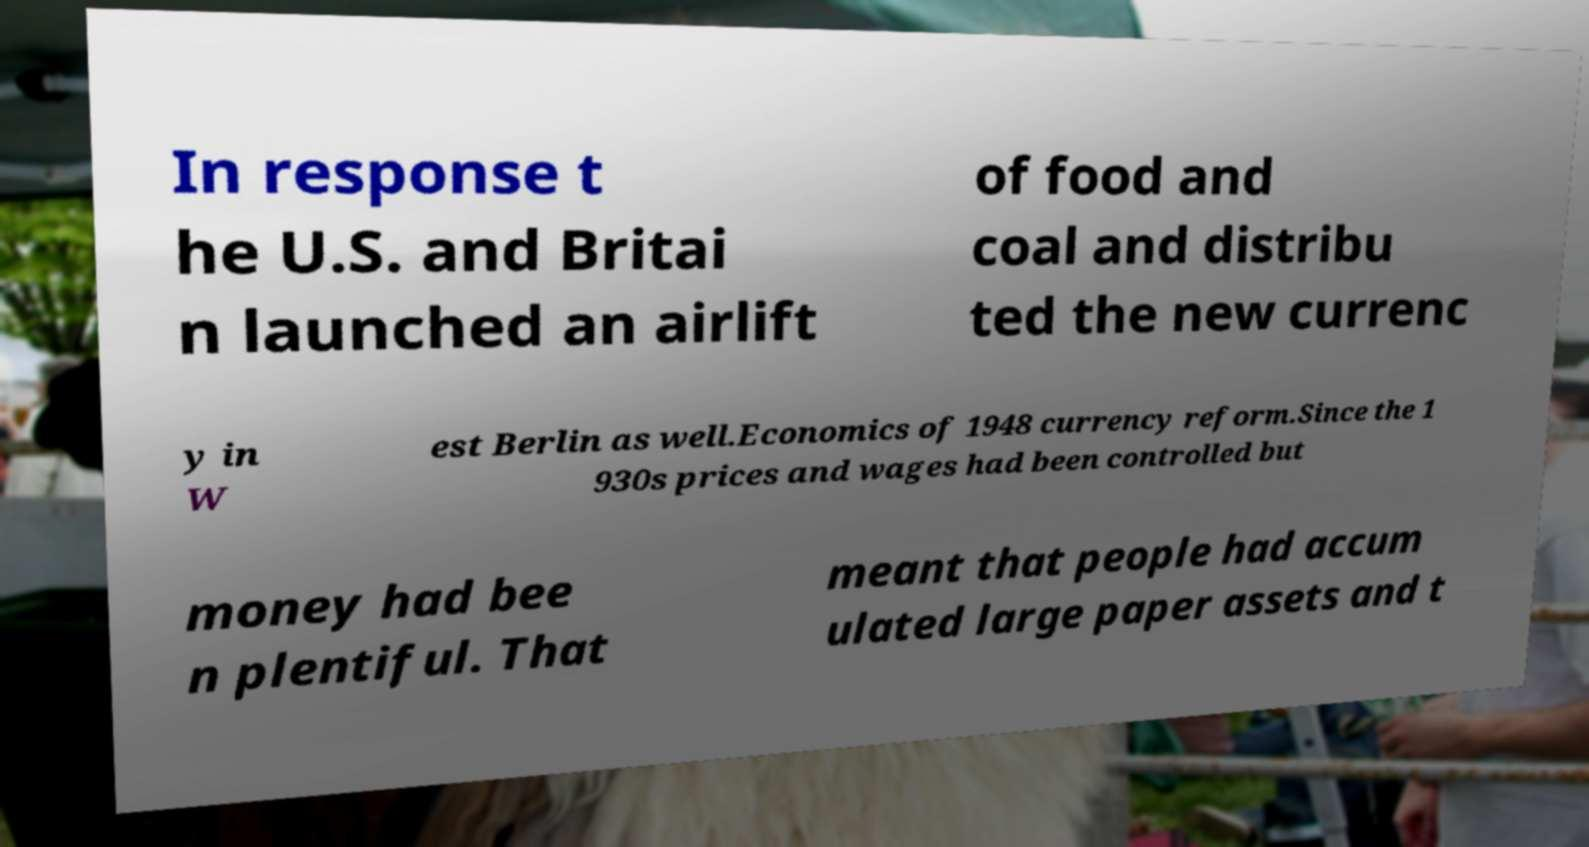I need the written content from this picture converted into text. Can you do that? In response t he U.S. and Britai n launched an airlift of food and coal and distribu ted the new currenc y in W est Berlin as well.Economics of 1948 currency reform.Since the 1 930s prices and wages had been controlled but money had bee n plentiful. That meant that people had accum ulated large paper assets and t 